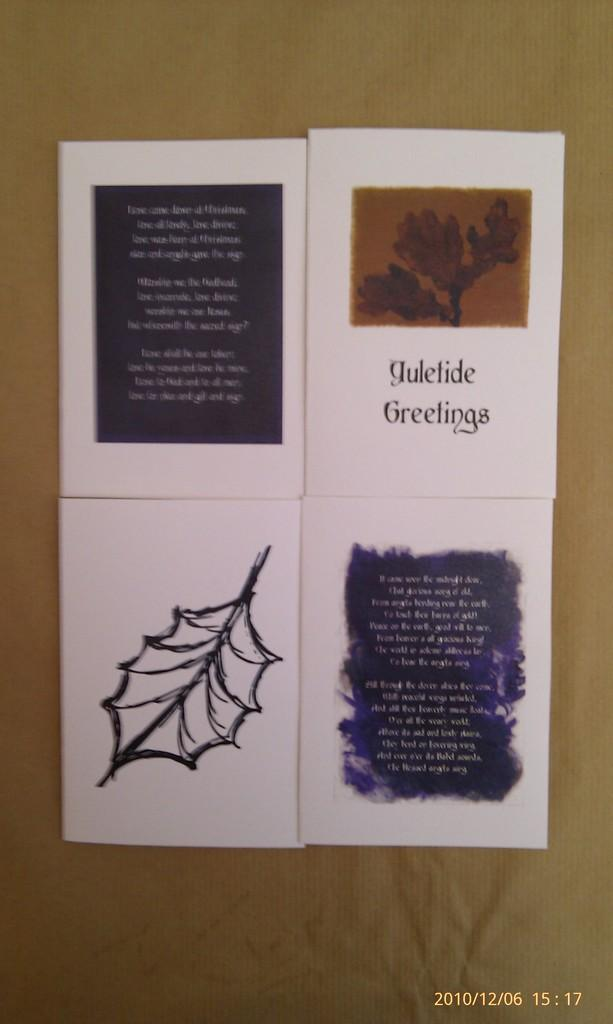<image>
Relay a brief, clear account of the picture shown. A flyer titled Yuletide Greeting and an image of a leaf on it. 